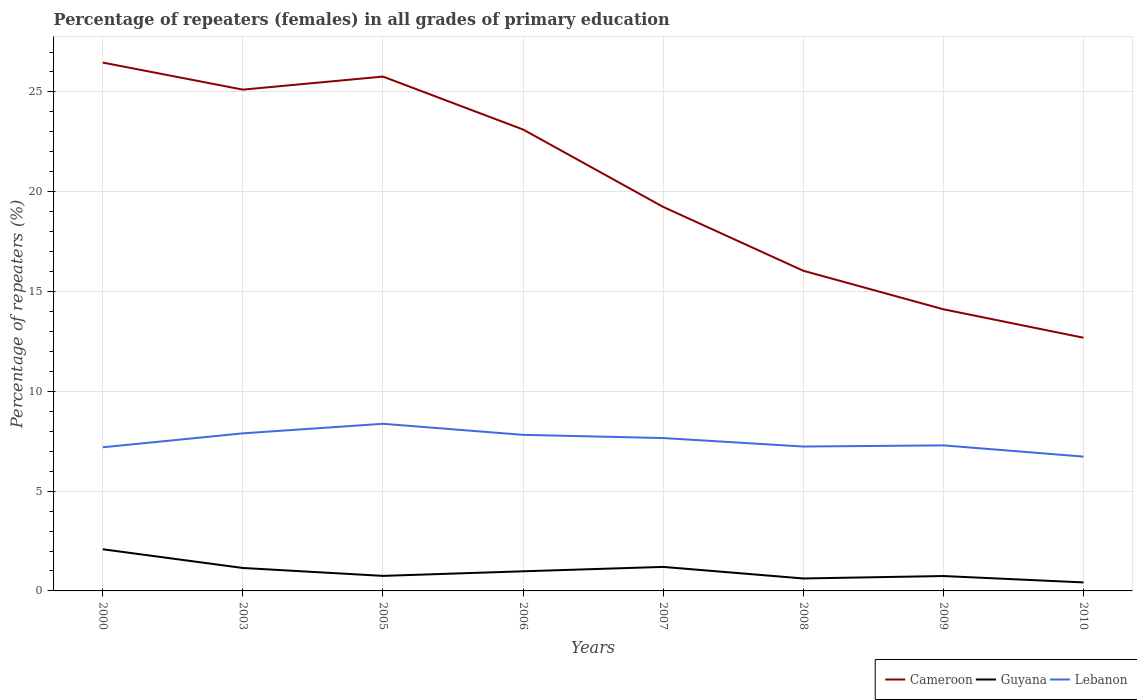Does the line corresponding to Cameroon intersect with the line corresponding to Lebanon?
Your answer should be compact. No. Is the number of lines equal to the number of legend labels?
Your answer should be compact. Yes. Across all years, what is the maximum percentage of repeaters (females) in Lebanon?
Your answer should be very brief. 6.73. What is the total percentage of repeaters (females) in Cameroon in the graph?
Ensure brevity in your answer.  6.55. What is the difference between the highest and the second highest percentage of repeaters (females) in Cameroon?
Your response must be concise. 13.79. What is the difference between the highest and the lowest percentage of repeaters (females) in Guyana?
Provide a succinct answer. 3. How many lines are there?
Provide a short and direct response. 3. How many years are there in the graph?
Offer a very short reply. 8. Are the values on the major ticks of Y-axis written in scientific E-notation?
Offer a very short reply. No. Where does the legend appear in the graph?
Offer a terse response. Bottom right. What is the title of the graph?
Provide a short and direct response. Percentage of repeaters (females) in all grades of primary education. What is the label or title of the X-axis?
Give a very brief answer. Years. What is the label or title of the Y-axis?
Your answer should be compact. Percentage of repeaters (%). What is the Percentage of repeaters (%) in Cameroon in 2000?
Keep it short and to the point. 26.47. What is the Percentage of repeaters (%) in Guyana in 2000?
Provide a short and direct response. 2.09. What is the Percentage of repeaters (%) in Lebanon in 2000?
Ensure brevity in your answer.  7.2. What is the Percentage of repeaters (%) in Cameroon in 2003?
Offer a very short reply. 25.11. What is the Percentage of repeaters (%) in Guyana in 2003?
Your answer should be very brief. 1.15. What is the Percentage of repeaters (%) in Lebanon in 2003?
Offer a terse response. 7.89. What is the Percentage of repeaters (%) in Cameroon in 2005?
Make the answer very short. 25.77. What is the Percentage of repeaters (%) of Guyana in 2005?
Offer a very short reply. 0.75. What is the Percentage of repeaters (%) in Lebanon in 2005?
Your response must be concise. 8.37. What is the Percentage of repeaters (%) of Cameroon in 2006?
Make the answer very short. 23.12. What is the Percentage of repeaters (%) in Guyana in 2006?
Give a very brief answer. 0.98. What is the Percentage of repeaters (%) of Lebanon in 2006?
Make the answer very short. 7.82. What is the Percentage of repeaters (%) of Cameroon in 2007?
Your answer should be very brief. 19.24. What is the Percentage of repeaters (%) of Guyana in 2007?
Ensure brevity in your answer.  1.2. What is the Percentage of repeaters (%) in Lebanon in 2007?
Your answer should be compact. 7.66. What is the Percentage of repeaters (%) in Cameroon in 2008?
Your answer should be very brief. 16.04. What is the Percentage of repeaters (%) in Guyana in 2008?
Provide a short and direct response. 0.62. What is the Percentage of repeaters (%) in Lebanon in 2008?
Give a very brief answer. 7.23. What is the Percentage of repeaters (%) in Cameroon in 2009?
Provide a short and direct response. 14.11. What is the Percentage of repeaters (%) of Guyana in 2009?
Offer a very short reply. 0.75. What is the Percentage of repeaters (%) in Lebanon in 2009?
Your response must be concise. 7.29. What is the Percentage of repeaters (%) of Cameroon in 2010?
Your answer should be compact. 12.69. What is the Percentage of repeaters (%) of Guyana in 2010?
Offer a very short reply. 0.43. What is the Percentage of repeaters (%) in Lebanon in 2010?
Your response must be concise. 6.73. Across all years, what is the maximum Percentage of repeaters (%) in Cameroon?
Give a very brief answer. 26.47. Across all years, what is the maximum Percentage of repeaters (%) in Guyana?
Provide a short and direct response. 2.09. Across all years, what is the maximum Percentage of repeaters (%) in Lebanon?
Provide a short and direct response. 8.37. Across all years, what is the minimum Percentage of repeaters (%) of Cameroon?
Keep it short and to the point. 12.69. Across all years, what is the minimum Percentage of repeaters (%) in Guyana?
Make the answer very short. 0.43. Across all years, what is the minimum Percentage of repeaters (%) in Lebanon?
Ensure brevity in your answer.  6.73. What is the total Percentage of repeaters (%) of Cameroon in the graph?
Provide a succinct answer. 162.55. What is the total Percentage of repeaters (%) in Guyana in the graph?
Your response must be concise. 7.97. What is the total Percentage of repeaters (%) in Lebanon in the graph?
Ensure brevity in your answer.  60.2. What is the difference between the Percentage of repeaters (%) in Cameroon in 2000 and that in 2003?
Keep it short and to the point. 1.36. What is the difference between the Percentage of repeaters (%) in Guyana in 2000 and that in 2003?
Make the answer very short. 0.94. What is the difference between the Percentage of repeaters (%) in Lebanon in 2000 and that in 2003?
Offer a terse response. -0.7. What is the difference between the Percentage of repeaters (%) in Cameroon in 2000 and that in 2005?
Your response must be concise. 0.7. What is the difference between the Percentage of repeaters (%) in Guyana in 2000 and that in 2005?
Your answer should be very brief. 1.33. What is the difference between the Percentage of repeaters (%) of Lebanon in 2000 and that in 2005?
Provide a succinct answer. -1.18. What is the difference between the Percentage of repeaters (%) in Cameroon in 2000 and that in 2006?
Make the answer very short. 3.35. What is the difference between the Percentage of repeaters (%) of Guyana in 2000 and that in 2006?
Provide a short and direct response. 1.1. What is the difference between the Percentage of repeaters (%) in Lebanon in 2000 and that in 2006?
Your response must be concise. -0.62. What is the difference between the Percentage of repeaters (%) in Cameroon in 2000 and that in 2007?
Keep it short and to the point. 7.23. What is the difference between the Percentage of repeaters (%) of Guyana in 2000 and that in 2007?
Your answer should be very brief. 0.88. What is the difference between the Percentage of repeaters (%) of Lebanon in 2000 and that in 2007?
Offer a terse response. -0.46. What is the difference between the Percentage of repeaters (%) of Cameroon in 2000 and that in 2008?
Provide a succinct answer. 10.43. What is the difference between the Percentage of repeaters (%) of Guyana in 2000 and that in 2008?
Keep it short and to the point. 1.46. What is the difference between the Percentage of repeaters (%) in Lebanon in 2000 and that in 2008?
Offer a very short reply. -0.04. What is the difference between the Percentage of repeaters (%) in Cameroon in 2000 and that in 2009?
Offer a very short reply. 12.36. What is the difference between the Percentage of repeaters (%) in Guyana in 2000 and that in 2009?
Provide a succinct answer. 1.34. What is the difference between the Percentage of repeaters (%) of Lebanon in 2000 and that in 2009?
Provide a short and direct response. -0.1. What is the difference between the Percentage of repeaters (%) in Cameroon in 2000 and that in 2010?
Your answer should be compact. 13.79. What is the difference between the Percentage of repeaters (%) of Guyana in 2000 and that in 2010?
Provide a short and direct response. 1.66. What is the difference between the Percentage of repeaters (%) in Lebanon in 2000 and that in 2010?
Give a very brief answer. 0.47. What is the difference between the Percentage of repeaters (%) of Cameroon in 2003 and that in 2005?
Your answer should be very brief. -0.65. What is the difference between the Percentage of repeaters (%) of Guyana in 2003 and that in 2005?
Make the answer very short. 0.4. What is the difference between the Percentage of repeaters (%) of Lebanon in 2003 and that in 2005?
Make the answer very short. -0.48. What is the difference between the Percentage of repeaters (%) of Cameroon in 2003 and that in 2006?
Provide a succinct answer. 2. What is the difference between the Percentage of repeaters (%) of Guyana in 2003 and that in 2006?
Offer a terse response. 0.17. What is the difference between the Percentage of repeaters (%) of Lebanon in 2003 and that in 2006?
Make the answer very short. 0.08. What is the difference between the Percentage of repeaters (%) in Cameroon in 2003 and that in 2007?
Your response must be concise. 5.87. What is the difference between the Percentage of repeaters (%) of Guyana in 2003 and that in 2007?
Your answer should be compact. -0.05. What is the difference between the Percentage of repeaters (%) in Lebanon in 2003 and that in 2007?
Offer a terse response. 0.24. What is the difference between the Percentage of repeaters (%) in Cameroon in 2003 and that in 2008?
Keep it short and to the point. 9.07. What is the difference between the Percentage of repeaters (%) in Guyana in 2003 and that in 2008?
Your response must be concise. 0.53. What is the difference between the Percentage of repeaters (%) of Lebanon in 2003 and that in 2008?
Offer a very short reply. 0.66. What is the difference between the Percentage of repeaters (%) in Cameroon in 2003 and that in 2009?
Provide a succinct answer. 11. What is the difference between the Percentage of repeaters (%) of Guyana in 2003 and that in 2009?
Make the answer very short. 0.4. What is the difference between the Percentage of repeaters (%) of Lebanon in 2003 and that in 2009?
Ensure brevity in your answer.  0.6. What is the difference between the Percentage of repeaters (%) of Cameroon in 2003 and that in 2010?
Make the answer very short. 12.43. What is the difference between the Percentage of repeaters (%) in Guyana in 2003 and that in 2010?
Your response must be concise. 0.72. What is the difference between the Percentage of repeaters (%) of Lebanon in 2003 and that in 2010?
Offer a very short reply. 1.17. What is the difference between the Percentage of repeaters (%) in Cameroon in 2005 and that in 2006?
Give a very brief answer. 2.65. What is the difference between the Percentage of repeaters (%) in Guyana in 2005 and that in 2006?
Ensure brevity in your answer.  -0.23. What is the difference between the Percentage of repeaters (%) in Lebanon in 2005 and that in 2006?
Offer a terse response. 0.55. What is the difference between the Percentage of repeaters (%) in Cameroon in 2005 and that in 2007?
Ensure brevity in your answer.  6.53. What is the difference between the Percentage of repeaters (%) of Guyana in 2005 and that in 2007?
Provide a short and direct response. -0.45. What is the difference between the Percentage of repeaters (%) of Lebanon in 2005 and that in 2007?
Provide a succinct answer. 0.71. What is the difference between the Percentage of repeaters (%) in Cameroon in 2005 and that in 2008?
Your response must be concise. 9.73. What is the difference between the Percentage of repeaters (%) in Guyana in 2005 and that in 2008?
Ensure brevity in your answer.  0.13. What is the difference between the Percentage of repeaters (%) of Lebanon in 2005 and that in 2008?
Provide a short and direct response. 1.14. What is the difference between the Percentage of repeaters (%) in Cameroon in 2005 and that in 2009?
Offer a very short reply. 11.66. What is the difference between the Percentage of repeaters (%) of Guyana in 2005 and that in 2009?
Offer a very short reply. 0.01. What is the difference between the Percentage of repeaters (%) of Lebanon in 2005 and that in 2009?
Provide a succinct answer. 1.08. What is the difference between the Percentage of repeaters (%) of Cameroon in 2005 and that in 2010?
Your response must be concise. 13.08. What is the difference between the Percentage of repeaters (%) in Guyana in 2005 and that in 2010?
Keep it short and to the point. 0.33. What is the difference between the Percentage of repeaters (%) in Lebanon in 2005 and that in 2010?
Provide a short and direct response. 1.64. What is the difference between the Percentage of repeaters (%) of Cameroon in 2006 and that in 2007?
Your answer should be very brief. 3.88. What is the difference between the Percentage of repeaters (%) of Guyana in 2006 and that in 2007?
Provide a short and direct response. -0.22. What is the difference between the Percentage of repeaters (%) in Lebanon in 2006 and that in 2007?
Make the answer very short. 0.16. What is the difference between the Percentage of repeaters (%) of Cameroon in 2006 and that in 2008?
Your answer should be compact. 7.08. What is the difference between the Percentage of repeaters (%) in Guyana in 2006 and that in 2008?
Keep it short and to the point. 0.36. What is the difference between the Percentage of repeaters (%) of Lebanon in 2006 and that in 2008?
Give a very brief answer. 0.59. What is the difference between the Percentage of repeaters (%) in Cameroon in 2006 and that in 2009?
Provide a short and direct response. 9.01. What is the difference between the Percentage of repeaters (%) in Guyana in 2006 and that in 2009?
Offer a very short reply. 0.24. What is the difference between the Percentage of repeaters (%) in Lebanon in 2006 and that in 2009?
Offer a very short reply. 0.53. What is the difference between the Percentage of repeaters (%) of Cameroon in 2006 and that in 2010?
Your answer should be very brief. 10.43. What is the difference between the Percentage of repeaters (%) in Guyana in 2006 and that in 2010?
Provide a succinct answer. 0.56. What is the difference between the Percentage of repeaters (%) of Lebanon in 2006 and that in 2010?
Your response must be concise. 1.09. What is the difference between the Percentage of repeaters (%) of Cameroon in 2007 and that in 2008?
Your answer should be compact. 3.2. What is the difference between the Percentage of repeaters (%) in Guyana in 2007 and that in 2008?
Ensure brevity in your answer.  0.58. What is the difference between the Percentage of repeaters (%) in Lebanon in 2007 and that in 2008?
Offer a terse response. 0.42. What is the difference between the Percentage of repeaters (%) in Cameroon in 2007 and that in 2009?
Give a very brief answer. 5.13. What is the difference between the Percentage of repeaters (%) of Guyana in 2007 and that in 2009?
Offer a very short reply. 0.46. What is the difference between the Percentage of repeaters (%) in Lebanon in 2007 and that in 2009?
Provide a short and direct response. 0.37. What is the difference between the Percentage of repeaters (%) of Cameroon in 2007 and that in 2010?
Ensure brevity in your answer.  6.55. What is the difference between the Percentage of repeaters (%) in Lebanon in 2007 and that in 2010?
Your answer should be very brief. 0.93. What is the difference between the Percentage of repeaters (%) of Cameroon in 2008 and that in 2009?
Give a very brief answer. 1.93. What is the difference between the Percentage of repeaters (%) of Guyana in 2008 and that in 2009?
Provide a short and direct response. -0.12. What is the difference between the Percentage of repeaters (%) of Lebanon in 2008 and that in 2009?
Ensure brevity in your answer.  -0.06. What is the difference between the Percentage of repeaters (%) of Cameroon in 2008 and that in 2010?
Offer a very short reply. 3.36. What is the difference between the Percentage of repeaters (%) of Guyana in 2008 and that in 2010?
Provide a short and direct response. 0.2. What is the difference between the Percentage of repeaters (%) in Lebanon in 2008 and that in 2010?
Offer a terse response. 0.5. What is the difference between the Percentage of repeaters (%) of Cameroon in 2009 and that in 2010?
Offer a terse response. 1.43. What is the difference between the Percentage of repeaters (%) in Guyana in 2009 and that in 2010?
Offer a very short reply. 0.32. What is the difference between the Percentage of repeaters (%) of Lebanon in 2009 and that in 2010?
Ensure brevity in your answer.  0.56. What is the difference between the Percentage of repeaters (%) in Cameroon in 2000 and the Percentage of repeaters (%) in Guyana in 2003?
Your answer should be compact. 25.32. What is the difference between the Percentage of repeaters (%) in Cameroon in 2000 and the Percentage of repeaters (%) in Lebanon in 2003?
Provide a short and direct response. 18.58. What is the difference between the Percentage of repeaters (%) of Guyana in 2000 and the Percentage of repeaters (%) of Lebanon in 2003?
Your response must be concise. -5.81. What is the difference between the Percentage of repeaters (%) of Cameroon in 2000 and the Percentage of repeaters (%) of Guyana in 2005?
Keep it short and to the point. 25.72. What is the difference between the Percentage of repeaters (%) in Cameroon in 2000 and the Percentage of repeaters (%) in Lebanon in 2005?
Offer a terse response. 18.1. What is the difference between the Percentage of repeaters (%) in Guyana in 2000 and the Percentage of repeaters (%) in Lebanon in 2005?
Ensure brevity in your answer.  -6.29. What is the difference between the Percentage of repeaters (%) of Cameroon in 2000 and the Percentage of repeaters (%) of Guyana in 2006?
Offer a very short reply. 25.49. What is the difference between the Percentage of repeaters (%) of Cameroon in 2000 and the Percentage of repeaters (%) of Lebanon in 2006?
Provide a succinct answer. 18.65. What is the difference between the Percentage of repeaters (%) in Guyana in 2000 and the Percentage of repeaters (%) in Lebanon in 2006?
Offer a terse response. -5.73. What is the difference between the Percentage of repeaters (%) of Cameroon in 2000 and the Percentage of repeaters (%) of Guyana in 2007?
Offer a terse response. 25.27. What is the difference between the Percentage of repeaters (%) in Cameroon in 2000 and the Percentage of repeaters (%) in Lebanon in 2007?
Ensure brevity in your answer.  18.81. What is the difference between the Percentage of repeaters (%) in Guyana in 2000 and the Percentage of repeaters (%) in Lebanon in 2007?
Your answer should be compact. -5.57. What is the difference between the Percentage of repeaters (%) in Cameroon in 2000 and the Percentage of repeaters (%) in Guyana in 2008?
Ensure brevity in your answer.  25.85. What is the difference between the Percentage of repeaters (%) of Cameroon in 2000 and the Percentage of repeaters (%) of Lebanon in 2008?
Ensure brevity in your answer.  19.24. What is the difference between the Percentage of repeaters (%) of Guyana in 2000 and the Percentage of repeaters (%) of Lebanon in 2008?
Ensure brevity in your answer.  -5.15. What is the difference between the Percentage of repeaters (%) of Cameroon in 2000 and the Percentage of repeaters (%) of Guyana in 2009?
Keep it short and to the point. 25.72. What is the difference between the Percentage of repeaters (%) of Cameroon in 2000 and the Percentage of repeaters (%) of Lebanon in 2009?
Give a very brief answer. 19.18. What is the difference between the Percentage of repeaters (%) in Guyana in 2000 and the Percentage of repeaters (%) in Lebanon in 2009?
Ensure brevity in your answer.  -5.2. What is the difference between the Percentage of repeaters (%) in Cameroon in 2000 and the Percentage of repeaters (%) in Guyana in 2010?
Your answer should be very brief. 26.05. What is the difference between the Percentage of repeaters (%) of Cameroon in 2000 and the Percentage of repeaters (%) of Lebanon in 2010?
Offer a very short reply. 19.74. What is the difference between the Percentage of repeaters (%) of Guyana in 2000 and the Percentage of repeaters (%) of Lebanon in 2010?
Make the answer very short. -4.64. What is the difference between the Percentage of repeaters (%) of Cameroon in 2003 and the Percentage of repeaters (%) of Guyana in 2005?
Provide a succinct answer. 24.36. What is the difference between the Percentage of repeaters (%) in Cameroon in 2003 and the Percentage of repeaters (%) in Lebanon in 2005?
Your answer should be compact. 16.74. What is the difference between the Percentage of repeaters (%) in Guyana in 2003 and the Percentage of repeaters (%) in Lebanon in 2005?
Give a very brief answer. -7.22. What is the difference between the Percentage of repeaters (%) in Cameroon in 2003 and the Percentage of repeaters (%) in Guyana in 2006?
Keep it short and to the point. 24.13. What is the difference between the Percentage of repeaters (%) of Cameroon in 2003 and the Percentage of repeaters (%) of Lebanon in 2006?
Your answer should be compact. 17.3. What is the difference between the Percentage of repeaters (%) in Guyana in 2003 and the Percentage of repeaters (%) in Lebanon in 2006?
Keep it short and to the point. -6.67. What is the difference between the Percentage of repeaters (%) of Cameroon in 2003 and the Percentage of repeaters (%) of Guyana in 2007?
Keep it short and to the point. 23.91. What is the difference between the Percentage of repeaters (%) in Cameroon in 2003 and the Percentage of repeaters (%) in Lebanon in 2007?
Provide a succinct answer. 17.46. What is the difference between the Percentage of repeaters (%) in Guyana in 2003 and the Percentage of repeaters (%) in Lebanon in 2007?
Your answer should be compact. -6.51. What is the difference between the Percentage of repeaters (%) of Cameroon in 2003 and the Percentage of repeaters (%) of Guyana in 2008?
Offer a terse response. 24.49. What is the difference between the Percentage of repeaters (%) of Cameroon in 2003 and the Percentage of repeaters (%) of Lebanon in 2008?
Ensure brevity in your answer.  17.88. What is the difference between the Percentage of repeaters (%) in Guyana in 2003 and the Percentage of repeaters (%) in Lebanon in 2008?
Your response must be concise. -6.08. What is the difference between the Percentage of repeaters (%) of Cameroon in 2003 and the Percentage of repeaters (%) of Guyana in 2009?
Provide a short and direct response. 24.37. What is the difference between the Percentage of repeaters (%) in Cameroon in 2003 and the Percentage of repeaters (%) in Lebanon in 2009?
Offer a terse response. 17.82. What is the difference between the Percentage of repeaters (%) of Guyana in 2003 and the Percentage of repeaters (%) of Lebanon in 2009?
Offer a very short reply. -6.14. What is the difference between the Percentage of repeaters (%) in Cameroon in 2003 and the Percentage of repeaters (%) in Guyana in 2010?
Offer a very short reply. 24.69. What is the difference between the Percentage of repeaters (%) in Cameroon in 2003 and the Percentage of repeaters (%) in Lebanon in 2010?
Your response must be concise. 18.39. What is the difference between the Percentage of repeaters (%) in Guyana in 2003 and the Percentage of repeaters (%) in Lebanon in 2010?
Make the answer very short. -5.58. What is the difference between the Percentage of repeaters (%) of Cameroon in 2005 and the Percentage of repeaters (%) of Guyana in 2006?
Make the answer very short. 24.79. What is the difference between the Percentage of repeaters (%) in Cameroon in 2005 and the Percentage of repeaters (%) in Lebanon in 2006?
Provide a succinct answer. 17.95. What is the difference between the Percentage of repeaters (%) in Guyana in 2005 and the Percentage of repeaters (%) in Lebanon in 2006?
Your answer should be very brief. -7.07. What is the difference between the Percentage of repeaters (%) in Cameroon in 2005 and the Percentage of repeaters (%) in Guyana in 2007?
Provide a short and direct response. 24.57. What is the difference between the Percentage of repeaters (%) in Cameroon in 2005 and the Percentage of repeaters (%) in Lebanon in 2007?
Offer a terse response. 18.11. What is the difference between the Percentage of repeaters (%) in Guyana in 2005 and the Percentage of repeaters (%) in Lebanon in 2007?
Provide a succinct answer. -6.91. What is the difference between the Percentage of repeaters (%) of Cameroon in 2005 and the Percentage of repeaters (%) of Guyana in 2008?
Your response must be concise. 25.15. What is the difference between the Percentage of repeaters (%) in Cameroon in 2005 and the Percentage of repeaters (%) in Lebanon in 2008?
Make the answer very short. 18.53. What is the difference between the Percentage of repeaters (%) of Guyana in 2005 and the Percentage of repeaters (%) of Lebanon in 2008?
Provide a short and direct response. -6.48. What is the difference between the Percentage of repeaters (%) in Cameroon in 2005 and the Percentage of repeaters (%) in Guyana in 2009?
Provide a succinct answer. 25.02. What is the difference between the Percentage of repeaters (%) of Cameroon in 2005 and the Percentage of repeaters (%) of Lebanon in 2009?
Offer a very short reply. 18.48. What is the difference between the Percentage of repeaters (%) in Guyana in 2005 and the Percentage of repeaters (%) in Lebanon in 2009?
Provide a short and direct response. -6.54. What is the difference between the Percentage of repeaters (%) of Cameroon in 2005 and the Percentage of repeaters (%) of Guyana in 2010?
Provide a succinct answer. 25.34. What is the difference between the Percentage of repeaters (%) in Cameroon in 2005 and the Percentage of repeaters (%) in Lebanon in 2010?
Your answer should be very brief. 19.04. What is the difference between the Percentage of repeaters (%) of Guyana in 2005 and the Percentage of repeaters (%) of Lebanon in 2010?
Make the answer very short. -5.98. What is the difference between the Percentage of repeaters (%) of Cameroon in 2006 and the Percentage of repeaters (%) of Guyana in 2007?
Give a very brief answer. 21.91. What is the difference between the Percentage of repeaters (%) in Cameroon in 2006 and the Percentage of repeaters (%) in Lebanon in 2007?
Provide a succinct answer. 15.46. What is the difference between the Percentage of repeaters (%) of Guyana in 2006 and the Percentage of repeaters (%) of Lebanon in 2007?
Your answer should be very brief. -6.68. What is the difference between the Percentage of repeaters (%) in Cameroon in 2006 and the Percentage of repeaters (%) in Guyana in 2008?
Your response must be concise. 22.49. What is the difference between the Percentage of repeaters (%) of Cameroon in 2006 and the Percentage of repeaters (%) of Lebanon in 2008?
Make the answer very short. 15.88. What is the difference between the Percentage of repeaters (%) in Guyana in 2006 and the Percentage of repeaters (%) in Lebanon in 2008?
Offer a terse response. -6.25. What is the difference between the Percentage of repeaters (%) of Cameroon in 2006 and the Percentage of repeaters (%) of Guyana in 2009?
Keep it short and to the point. 22.37. What is the difference between the Percentage of repeaters (%) in Cameroon in 2006 and the Percentage of repeaters (%) in Lebanon in 2009?
Keep it short and to the point. 15.83. What is the difference between the Percentage of repeaters (%) in Guyana in 2006 and the Percentage of repeaters (%) in Lebanon in 2009?
Offer a very short reply. -6.31. What is the difference between the Percentage of repeaters (%) in Cameroon in 2006 and the Percentage of repeaters (%) in Guyana in 2010?
Your response must be concise. 22.69. What is the difference between the Percentage of repeaters (%) of Cameroon in 2006 and the Percentage of repeaters (%) of Lebanon in 2010?
Make the answer very short. 16.39. What is the difference between the Percentage of repeaters (%) of Guyana in 2006 and the Percentage of repeaters (%) of Lebanon in 2010?
Provide a short and direct response. -5.75. What is the difference between the Percentage of repeaters (%) in Cameroon in 2007 and the Percentage of repeaters (%) in Guyana in 2008?
Your answer should be compact. 18.62. What is the difference between the Percentage of repeaters (%) of Cameroon in 2007 and the Percentage of repeaters (%) of Lebanon in 2008?
Keep it short and to the point. 12.01. What is the difference between the Percentage of repeaters (%) in Guyana in 2007 and the Percentage of repeaters (%) in Lebanon in 2008?
Keep it short and to the point. -6.03. What is the difference between the Percentage of repeaters (%) of Cameroon in 2007 and the Percentage of repeaters (%) of Guyana in 2009?
Your answer should be compact. 18.49. What is the difference between the Percentage of repeaters (%) in Cameroon in 2007 and the Percentage of repeaters (%) in Lebanon in 2009?
Provide a succinct answer. 11.95. What is the difference between the Percentage of repeaters (%) in Guyana in 2007 and the Percentage of repeaters (%) in Lebanon in 2009?
Offer a terse response. -6.09. What is the difference between the Percentage of repeaters (%) in Cameroon in 2007 and the Percentage of repeaters (%) in Guyana in 2010?
Provide a short and direct response. 18.81. What is the difference between the Percentage of repeaters (%) of Cameroon in 2007 and the Percentage of repeaters (%) of Lebanon in 2010?
Make the answer very short. 12.51. What is the difference between the Percentage of repeaters (%) in Guyana in 2007 and the Percentage of repeaters (%) in Lebanon in 2010?
Make the answer very short. -5.53. What is the difference between the Percentage of repeaters (%) of Cameroon in 2008 and the Percentage of repeaters (%) of Guyana in 2009?
Your answer should be compact. 15.3. What is the difference between the Percentage of repeaters (%) in Cameroon in 2008 and the Percentage of repeaters (%) in Lebanon in 2009?
Your answer should be compact. 8.75. What is the difference between the Percentage of repeaters (%) of Guyana in 2008 and the Percentage of repeaters (%) of Lebanon in 2009?
Keep it short and to the point. -6.67. What is the difference between the Percentage of repeaters (%) in Cameroon in 2008 and the Percentage of repeaters (%) in Guyana in 2010?
Give a very brief answer. 15.62. What is the difference between the Percentage of repeaters (%) of Cameroon in 2008 and the Percentage of repeaters (%) of Lebanon in 2010?
Your response must be concise. 9.31. What is the difference between the Percentage of repeaters (%) of Guyana in 2008 and the Percentage of repeaters (%) of Lebanon in 2010?
Keep it short and to the point. -6.11. What is the difference between the Percentage of repeaters (%) in Cameroon in 2009 and the Percentage of repeaters (%) in Guyana in 2010?
Your answer should be compact. 13.69. What is the difference between the Percentage of repeaters (%) in Cameroon in 2009 and the Percentage of repeaters (%) in Lebanon in 2010?
Your response must be concise. 7.38. What is the difference between the Percentage of repeaters (%) in Guyana in 2009 and the Percentage of repeaters (%) in Lebanon in 2010?
Your response must be concise. -5.98. What is the average Percentage of repeaters (%) in Cameroon per year?
Ensure brevity in your answer.  20.32. What is the average Percentage of repeaters (%) of Lebanon per year?
Offer a very short reply. 7.52. In the year 2000, what is the difference between the Percentage of repeaters (%) of Cameroon and Percentage of repeaters (%) of Guyana?
Offer a terse response. 24.38. In the year 2000, what is the difference between the Percentage of repeaters (%) of Cameroon and Percentage of repeaters (%) of Lebanon?
Make the answer very short. 19.27. In the year 2000, what is the difference between the Percentage of repeaters (%) in Guyana and Percentage of repeaters (%) in Lebanon?
Provide a short and direct response. -5.11. In the year 2003, what is the difference between the Percentage of repeaters (%) of Cameroon and Percentage of repeaters (%) of Guyana?
Provide a succinct answer. 23.97. In the year 2003, what is the difference between the Percentage of repeaters (%) in Cameroon and Percentage of repeaters (%) in Lebanon?
Your response must be concise. 17.22. In the year 2003, what is the difference between the Percentage of repeaters (%) of Guyana and Percentage of repeaters (%) of Lebanon?
Keep it short and to the point. -6.75. In the year 2005, what is the difference between the Percentage of repeaters (%) in Cameroon and Percentage of repeaters (%) in Guyana?
Offer a terse response. 25.02. In the year 2005, what is the difference between the Percentage of repeaters (%) in Cameroon and Percentage of repeaters (%) in Lebanon?
Your answer should be very brief. 17.4. In the year 2005, what is the difference between the Percentage of repeaters (%) in Guyana and Percentage of repeaters (%) in Lebanon?
Provide a succinct answer. -7.62. In the year 2006, what is the difference between the Percentage of repeaters (%) in Cameroon and Percentage of repeaters (%) in Guyana?
Ensure brevity in your answer.  22.13. In the year 2006, what is the difference between the Percentage of repeaters (%) of Cameroon and Percentage of repeaters (%) of Lebanon?
Provide a succinct answer. 15.3. In the year 2006, what is the difference between the Percentage of repeaters (%) of Guyana and Percentage of repeaters (%) of Lebanon?
Your response must be concise. -6.84. In the year 2007, what is the difference between the Percentage of repeaters (%) in Cameroon and Percentage of repeaters (%) in Guyana?
Offer a very short reply. 18.04. In the year 2007, what is the difference between the Percentage of repeaters (%) in Cameroon and Percentage of repeaters (%) in Lebanon?
Keep it short and to the point. 11.58. In the year 2007, what is the difference between the Percentage of repeaters (%) of Guyana and Percentage of repeaters (%) of Lebanon?
Your answer should be compact. -6.46. In the year 2008, what is the difference between the Percentage of repeaters (%) of Cameroon and Percentage of repeaters (%) of Guyana?
Offer a very short reply. 15.42. In the year 2008, what is the difference between the Percentage of repeaters (%) in Cameroon and Percentage of repeaters (%) in Lebanon?
Give a very brief answer. 8.81. In the year 2008, what is the difference between the Percentage of repeaters (%) of Guyana and Percentage of repeaters (%) of Lebanon?
Provide a short and direct response. -6.61. In the year 2009, what is the difference between the Percentage of repeaters (%) of Cameroon and Percentage of repeaters (%) of Guyana?
Make the answer very short. 13.36. In the year 2009, what is the difference between the Percentage of repeaters (%) in Cameroon and Percentage of repeaters (%) in Lebanon?
Your response must be concise. 6.82. In the year 2009, what is the difference between the Percentage of repeaters (%) in Guyana and Percentage of repeaters (%) in Lebanon?
Ensure brevity in your answer.  -6.55. In the year 2010, what is the difference between the Percentage of repeaters (%) of Cameroon and Percentage of repeaters (%) of Guyana?
Provide a succinct answer. 12.26. In the year 2010, what is the difference between the Percentage of repeaters (%) in Cameroon and Percentage of repeaters (%) in Lebanon?
Keep it short and to the point. 5.96. In the year 2010, what is the difference between the Percentage of repeaters (%) in Guyana and Percentage of repeaters (%) in Lebanon?
Keep it short and to the point. -6.3. What is the ratio of the Percentage of repeaters (%) in Cameroon in 2000 to that in 2003?
Provide a short and direct response. 1.05. What is the ratio of the Percentage of repeaters (%) of Guyana in 2000 to that in 2003?
Ensure brevity in your answer.  1.82. What is the ratio of the Percentage of repeaters (%) in Lebanon in 2000 to that in 2003?
Your answer should be compact. 0.91. What is the ratio of the Percentage of repeaters (%) in Cameroon in 2000 to that in 2005?
Give a very brief answer. 1.03. What is the ratio of the Percentage of repeaters (%) in Guyana in 2000 to that in 2005?
Make the answer very short. 2.77. What is the ratio of the Percentage of repeaters (%) of Lebanon in 2000 to that in 2005?
Offer a very short reply. 0.86. What is the ratio of the Percentage of repeaters (%) in Cameroon in 2000 to that in 2006?
Offer a terse response. 1.15. What is the ratio of the Percentage of repeaters (%) in Guyana in 2000 to that in 2006?
Provide a succinct answer. 2.12. What is the ratio of the Percentage of repeaters (%) of Lebanon in 2000 to that in 2006?
Provide a short and direct response. 0.92. What is the ratio of the Percentage of repeaters (%) in Cameroon in 2000 to that in 2007?
Your answer should be very brief. 1.38. What is the ratio of the Percentage of repeaters (%) of Guyana in 2000 to that in 2007?
Provide a short and direct response. 1.73. What is the ratio of the Percentage of repeaters (%) of Lebanon in 2000 to that in 2007?
Provide a succinct answer. 0.94. What is the ratio of the Percentage of repeaters (%) of Cameroon in 2000 to that in 2008?
Make the answer very short. 1.65. What is the ratio of the Percentage of repeaters (%) in Guyana in 2000 to that in 2008?
Keep it short and to the point. 3.35. What is the ratio of the Percentage of repeaters (%) in Cameroon in 2000 to that in 2009?
Provide a succinct answer. 1.88. What is the ratio of the Percentage of repeaters (%) in Guyana in 2000 to that in 2009?
Your answer should be compact. 2.8. What is the ratio of the Percentage of repeaters (%) in Lebanon in 2000 to that in 2009?
Ensure brevity in your answer.  0.99. What is the ratio of the Percentage of repeaters (%) of Cameroon in 2000 to that in 2010?
Provide a succinct answer. 2.09. What is the ratio of the Percentage of repeaters (%) of Guyana in 2000 to that in 2010?
Provide a succinct answer. 4.9. What is the ratio of the Percentage of repeaters (%) of Lebanon in 2000 to that in 2010?
Offer a very short reply. 1.07. What is the ratio of the Percentage of repeaters (%) in Cameroon in 2003 to that in 2005?
Your response must be concise. 0.97. What is the ratio of the Percentage of repeaters (%) in Guyana in 2003 to that in 2005?
Give a very brief answer. 1.53. What is the ratio of the Percentage of repeaters (%) of Lebanon in 2003 to that in 2005?
Ensure brevity in your answer.  0.94. What is the ratio of the Percentage of repeaters (%) of Cameroon in 2003 to that in 2006?
Make the answer very short. 1.09. What is the ratio of the Percentage of repeaters (%) in Guyana in 2003 to that in 2006?
Offer a very short reply. 1.17. What is the ratio of the Percentage of repeaters (%) of Lebanon in 2003 to that in 2006?
Keep it short and to the point. 1.01. What is the ratio of the Percentage of repeaters (%) of Cameroon in 2003 to that in 2007?
Your answer should be very brief. 1.31. What is the ratio of the Percentage of repeaters (%) in Guyana in 2003 to that in 2007?
Make the answer very short. 0.96. What is the ratio of the Percentage of repeaters (%) in Lebanon in 2003 to that in 2007?
Ensure brevity in your answer.  1.03. What is the ratio of the Percentage of repeaters (%) of Cameroon in 2003 to that in 2008?
Your answer should be very brief. 1.57. What is the ratio of the Percentage of repeaters (%) in Guyana in 2003 to that in 2008?
Your answer should be very brief. 1.84. What is the ratio of the Percentage of repeaters (%) of Lebanon in 2003 to that in 2008?
Your response must be concise. 1.09. What is the ratio of the Percentage of repeaters (%) of Cameroon in 2003 to that in 2009?
Your answer should be very brief. 1.78. What is the ratio of the Percentage of repeaters (%) of Guyana in 2003 to that in 2009?
Offer a very short reply. 1.54. What is the ratio of the Percentage of repeaters (%) in Lebanon in 2003 to that in 2009?
Your response must be concise. 1.08. What is the ratio of the Percentage of repeaters (%) in Cameroon in 2003 to that in 2010?
Your answer should be very brief. 1.98. What is the ratio of the Percentage of repeaters (%) in Guyana in 2003 to that in 2010?
Your answer should be very brief. 2.7. What is the ratio of the Percentage of repeaters (%) of Lebanon in 2003 to that in 2010?
Keep it short and to the point. 1.17. What is the ratio of the Percentage of repeaters (%) of Cameroon in 2005 to that in 2006?
Keep it short and to the point. 1.11. What is the ratio of the Percentage of repeaters (%) of Guyana in 2005 to that in 2006?
Keep it short and to the point. 0.77. What is the ratio of the Percentage of repeaters (%) in Lebanon in 2005 to that in 2006?
Ensure brevity in your answer.  1.07. What is the ratio of the Percentage of repeaters (%) of Cameroon in 2005 to that in 2007?
Make the answer very short. 1.34. What is the ratio of the Percentage of repeaters (%) in Guyana in 2005 to that in 2007?
Provide a succinct answer. 0.63. What is the ratio of the Percentage of repeaters (%) of Lebanon in 2005 to that in 2007?
Make the answer very short. 1.09. What is the ratio of the Percentage of repeaters (%) in Cameroon in 2005 to that in 2008?
Provide a succinct answer. 1.61. What is the ratio of the Percentage of repeaters (%) of Guyana in 2005 to that in 2008?
Provide a short and direct response. 1.21. What is the ratio of the Percentage of repeaters (%) of Lebanon in 2005 to that in 2008?
Provide a short and direct response. 1.16. What is the ratio of the Percentage of repeaters (%) of Cameroon in 2005 to that in 2009?
Your answer should be compact. 1.83. What is the ratio of the Percentage of repeaters (%) of Guyana in 2005 to that in 2009?
Offer a terse response. 1.01. What is the ratio of the Percentage of repeaters (%) in Lebanon in 2005 to that in 2009?
Your answer should be compact. 1.15. What is the ratio of the Percentage of repeaters (%) of Cameroon in 2005 to that in 2010?
Provide a succinct answer. 2.03. What is the ratio of the Percentage of repeaters (%) of Guyana in 2005 to that in 2010?
Your response must be concise. 1.77. What is the ratio of the Percentage of repeaters (%) in Lebanon in 2005 to that in 2010?
Your response must be concise. 1.24. What is the ratio of the Percentage of repeaters (%) in Cameroon in 2006 to that in 2007?
Make the answer very short. 1.2. What is the ratio of the Percentage of repeaters (%) in Guyana in 2006 to that in 2007?
Provide a short and direct response. 0.82. What is the ratio of the Percentage of repeaters (%) of Lebanon in 2006 to that in 2007?
Provide a short and direct response. 1.02. What is the ratio of the Percentage of repeaters (%) of Cameroon in 2006 to that in 2008?
Provide a short and direct response. 1.44. What is the ratio of the Percentage of repeaters (%) in Guyana in 2006 to that in 2008?
Offer a very short reply. 1.58. What is the ratio of the Percentage of repeaters (%) in Lebanon in 2006 to that in 2008?
Give a very brief answer. 1.08. What is the ratio of the Percentage of repeaters (%) in Cameroon in 2006 to that in 2009?
Your answer should be very brief. 1.64. What is the ratio of the Percentage of repeaters (%) of Guyana in 2006 to that in 2009?
Ensure brevity in your answer.  1.32. What is the ratio of the Percentage of repeaters (%) in Lebanon in 2006 to that in 2009?
Give a very brief answer. 1.07. What is the ratio of the Percentage of repeaters (%) in Cameroon in 2006 to that in 2010?
Your answer should be compact. 1.82. What is the ratio of the Percentage of repeaters (%) in Guyana in 2006 to that in 2010?
Offer a terse response. 2.31. What is the ratio of the Percentage of repeaters (%) in Lebanon in 2006 to that in 2010?
Ensure brevity in your answer.  1.16. What is the ratio of the Percentage of repeaters (%) in Cameroon in 2007 to that in 2008?
Keep it short and to the point. 1.2. What is the ratio of the Percentage of repeaters (%) in Guyana in 2007 to that in 2008?
Offer a very short reply. 1.93. What is the ratio of the Percentage of repeaters (%) in Lebanon in 2007 to that in 2008?
Your response must be concise. 1.06. What is the ratio of the Percentage of repeaters (%) in Cameroon in 2007 to that in 2009?
Your response must be concise. 1.36. What is the ratio of the Percentage of repeaters (%) of Guyana in 2007 to that in 2009?
Offer a very short reply. 1.61. What is the ratio of the Percentage of repeaters (%) in Lebanon in 2007 to that in 2009?
Ensure brevity in your answer.  1.05. What is the ratio of the Percentage of repeaters (%) of Cameroon in 2007 to that in 2010?
Your response must be concise. 1.52. What is the ratio of the Percentage of repeaters (%) of Guyana in 2007 to that in 2010?
Offer a very short reply. 2.83. What is the ratio of the Percentage of repeaters (%) of Lebanon in 2007 to that in 2010?
Ensure brevity in your answer.  1.14. What is the ratio of the Percentage of repeaters (%) of Cameroon in 2008 to that in 2009?
Make the answer very short. 1.14. What is the ratio of the Percentage of repeaters (%) in Guyana in 2008 to that in 2009?
Make the answer very short. 0.84. What is the ratio of the Percentage of repeaters (%) in Lebanon in 2008 to that in 2009?
Give a very brief answer. 0.99. What is the ratio of the Percentage of repeaters (%) in Cameroon in 2008 to that in 2010?
Give a very brief answer. 1.26. What is the ratio of the Percentage of repeaters (%) in Guyana in 2008 to that in 2010?
Make the answer very short. 1.47. What is the ratio of the Percentage of repeaters (%) of Lebanon in 2008 to that in 2010?
Give a very brief answer. 1.07. What is the ratio of the Percentage of repeaters (%) in Cameroon in 2009 to that in 2010?
Give a very brief answer. 1.11. What is the ratio of the Percentage of repeaters (%) of Guyana in 2009 to that in 2010?
Keep it short and to the point. 1.75. What is the ratio of the Percentage of repeaters (%) of Lebanon in 2009 to that in 2010?
Make the answer very short. 1.08. What is the difference between the highest and the second highest Percentage of repeaters (%) of Cameroon?
Give a very brief answer. 0.7. What is the difference between the highest and the second highest Percentage of repeaters (%) of Guyana?
Make the answer very short. 0.88. What is the difference between the highest and the second highest Percentage of repeaters (%) in Lebanon?
Your answer should be compact. 0.48. What is the difference between the highest and the lowest Percentage of repeaters (%) in Cameroon?
Provide a short and direct response. 13.79. What is the difference between the highest and the lowest Percentage of repeaters (%) in Guyana?
Keep it short and to the point. 1.66. What is the difference between the highest and the lowest Percentage of repeaters (%) of Lebanon?
Your answer should be very brief. 1.64. 